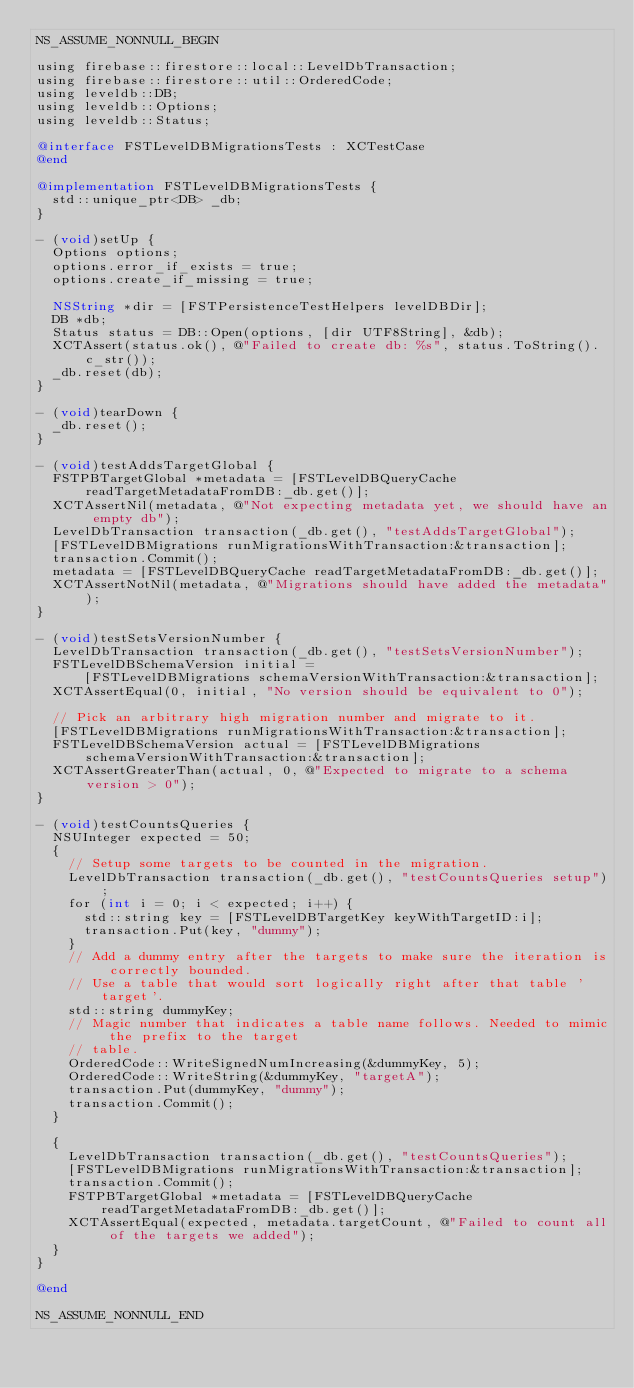<code> <loc_0><loc_0><loc_500><loc_500><_ObjectiveC_>NS_ASSUME_NONNULL_BEGIN

using firebase::firestore::local::LevelDbTransaction;
using firebase::firestore::util::OrderedCode;
using leveldb::DB;
using leveldb::Options;
using leveldb::Status;

@interface FSTLevelDBMigrationsTests : XCTestCase
@end

@implementation FSTLevelDBMigrationsTests {
  std::unique_ptr<DB> _db;
}

- (void)setUp {
  Options options;
  options.error_if_exists = true;
  options.create_if_missing = true;

  NSString *dir = [FSTPersistenceTestHelpers levelDBDir];
  DB *db;
  Status status = DB::Open(options, [dir UTF8String], &db);
  XCTAssert(status.ok(), @"Failed to create db: %s", status.ToString().c_str());
  _db.reset(db);
}

- (void)tearDown {
  _db.reset();
}

- (void)testAddsTargetGlobal {
  FSTPBTargetGlobal *metadata = [FSTLevelDBQueryCache readTargetMetadataFromDB:_db.get()];
  XCTAssertNil(metadata, @"Not expecting metadata yet, we should have an empty db");
  LevelDbTransaction transaction(_db.get(), "testAddsTargetGlobal");
  [FSTLevelDBMigrations runMigrationsWithTransaction:&transaction];
  transaction.Commit();
  metadata = [FSTLevelDBQueryCache readTargetMetadataFromDB:_db.get()];
  XCTAssertNotNil(metadata, @"Migrations should have added the metadata");
}

- (void)testSetsVersionNumber {
  LevelDbTransaction transaction(_db.get(), "testSetsVersionNumber");
  FSTLevelDBSchemaVersion initial =
      [FSTLevelDBMigrations schemaVersionWithTransaction:&transaction];
  XCTAssertEqual(0, initial, "No version should be equivalent to 0");

  // Pick an arbitrary high migration number and migrate to it.
  [FSTLevelDBMigrations runMigrationsWithTransaction:&transaction];
  FSTLevelDBSchemaVersion actual = [FSTLevelDBMigrations schemaVersionWithTransaction:&transaction];
  XCTAssertGreaterThan(actual, 0, @"Expected to migrate to a schema version > 0");
}

- (void)testCountsQueries {
  NSUInteger expected = 50;
  {
    // Setup some targets to be counted in the migration.
    LevelDbTransaction transaction(_db.get(), "testCountsQueries setup");
    for (int i = 0; i < expected; i++) {
      std::string key = [FSTLevelDBTargetKey keyWithTargetID:i];
      transaction.Put(key, "dummy");
    }
    // Add a dummy entry after the targets to make sure the iteration is correctly bounded.
    // Use a table that would sort logically right after that table 'target'.
    std::string dummyKey;
    // Magic number that indicates a table name follows. Needed to mimic the prefix to the target
    // table.
    OrderedCode::WriteSignedNumIncreasing(&dummyKey, 5);
    OrderedCode::WriteString(&dummyKey, "targetA");
    transaction.Put(dummyKey, "dummy");
    transaction.Commit();
  }

  {
    LevelDbTransaction transaction(_db.get(), "testCountsQueries");
    [FSTLevelDBMigrations runMigrationsWithTransaction:&transaction];
    transaction.Commit();
    FSTPBTargetGlobal *metadata = [FSTLevelDBQueryCache readTargetMetadataFromDB:_db.get()];
    XCTAssertEqual(expected, metadata.targetCount, @"Failed to count all of the targets we added");
  }
}

@end

NS_ASSUME_NONNULL_END
</code> 